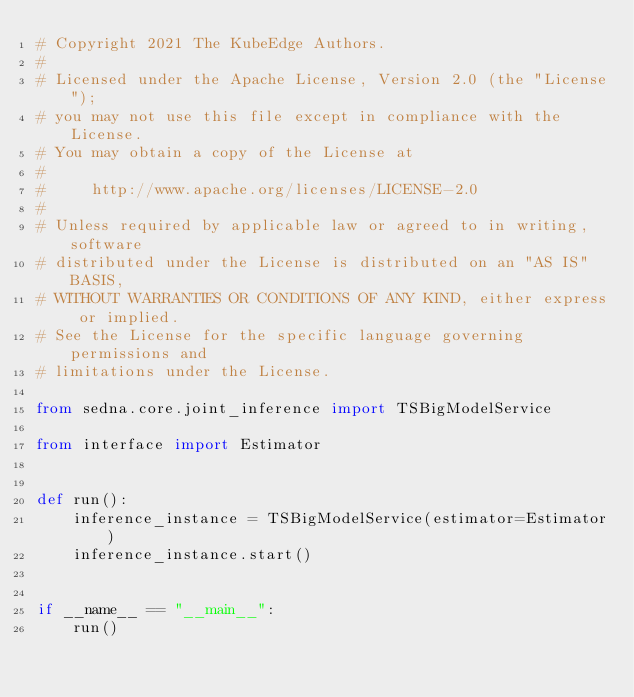<code> <loc_0><loc_0><loc_500><loc_500><_Python_># Copyright 2021 The KubeEdge Authors.
#
# Licensed under the Apache License, Version 2.0 (the "License");
# you may not use this file except in compliance with the License.
# You may obtain a copy of the License at
#
#     http://www.apache.org/licenses/LICENSE-2.0
#
# Unless required by applicable law or agreed to in writing, software
# distributed under the License is distributed on an "AS IS" BASIS,
# WITHOUT WARRANTIES OR CONDITIONS OF ANY KIND, either express or implied.
# See the License for the specific language governing permissions and
# limitations under the License.

from sedna.core.joint_inference import TSBigModelService

from interface import Estimator


def run():
    inference_instance = TSBigModelService(estimator=Estimator)
    inference_instance.start()


if __name__ == "__main__":
    run()
</code> 